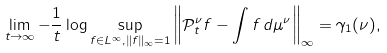Convert formula to latex. <formula><loc_0><loc_0><loc_500><loc_500>\lim _ { t \rightarrow \infty } - \frac { 1 } { t } \log \sup _ { f \in L ^ { \infty } , \| f \| _ { \infty } = 1 } \left \| \mathcal { P } _ { t } ^ { \nu } f - \int f \, d \mu ^ { \nu } \right \| _ { \infty } = \gamma _ { 1 } ( \nu ) ,</formula> 